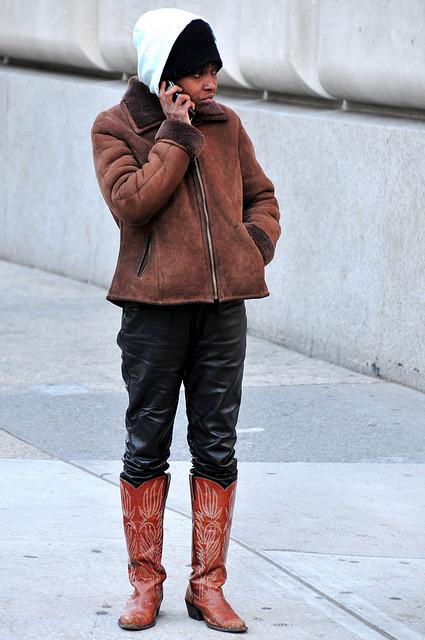What color is this person's boots?
Keep it brief. Brown. What color is the personhood?
Keep it brief. White. What kind of shoes is the person wearing?
Give a very brief answer. Boots. 